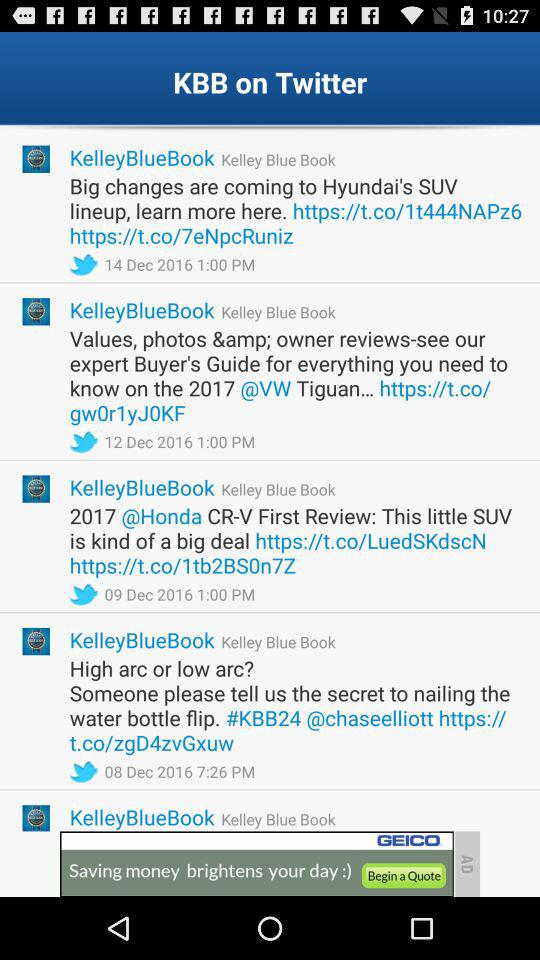How much less is the Dealer Invoice than the MSRP?
Answer the question using a single word or phrase. $1631 